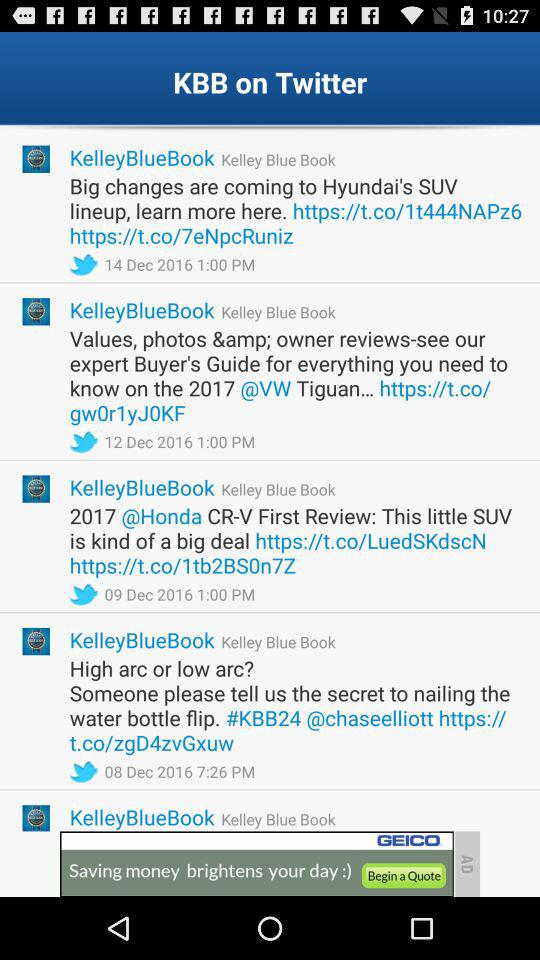How much less is the Dealer Invoice than the MSRP?
Answer the question using a single word or phrase. $1631 